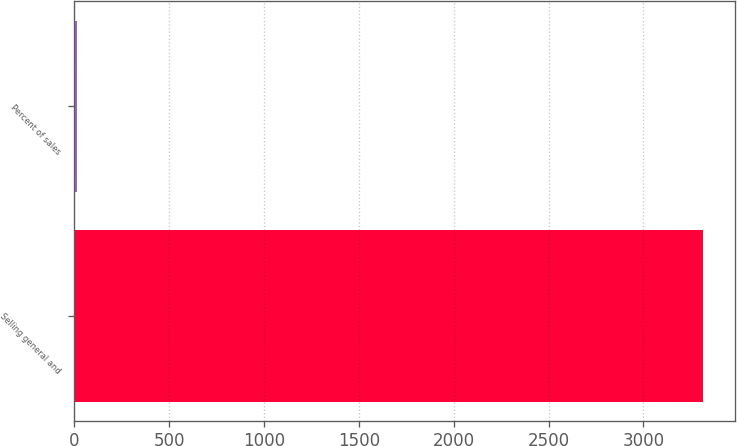Convert chart. <chart><loc_0><loc_0><loc_500><loc_500><bar_chart><fcel>Selling general and<fcel>Percent of sales<nl><fcel>3316<fcel>13<nl></chart> 